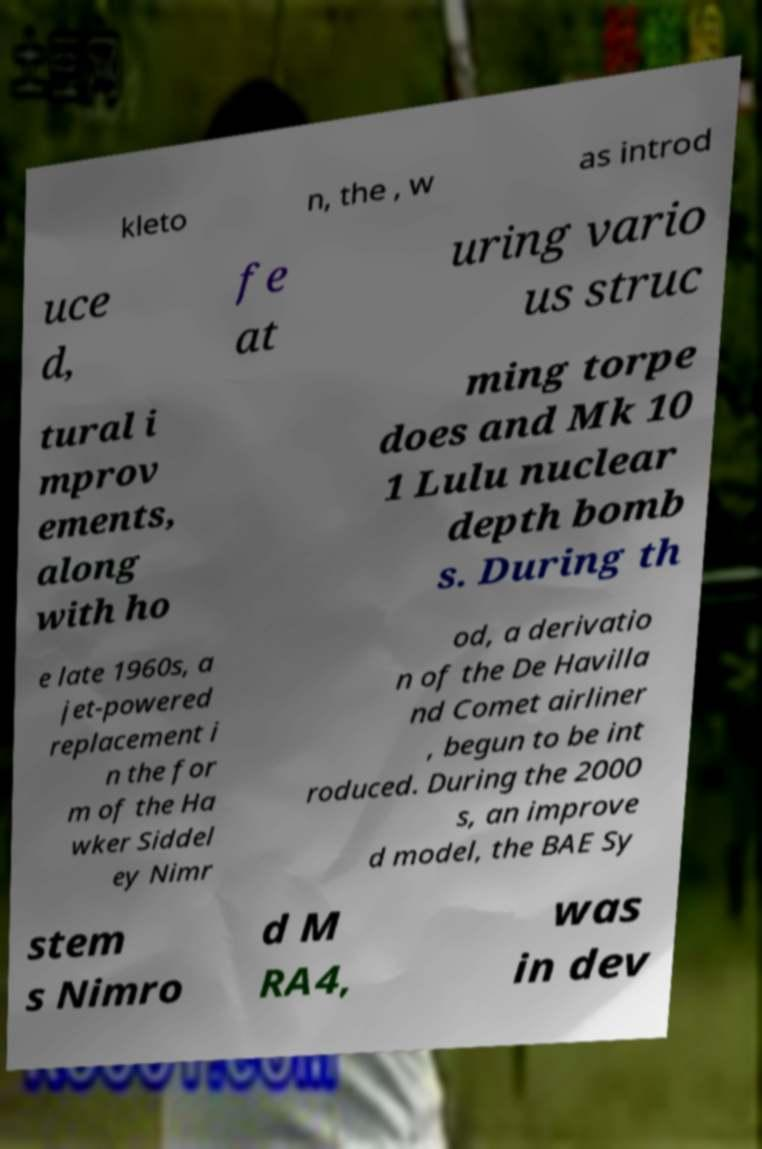For documentation purposes, I need the text within this image transcribed. Could you provide that? kleto n, the , w as introd uce d, fe at uring vario us struc tural i mprov ements, along with ho ming torpe does and Mk 10 1 Lulu nuclear depth bomb s. During th e late 1960s, a jet-powered replacement i n the for m of the Ha wker Siddel ey Nimr od, a derivatio n of the De Havilla nd Comet airliner , begun to be int roduced. During the 2000 s, an improve d model, the BAE Sy stem s Nimro d M RA4, was in dev 